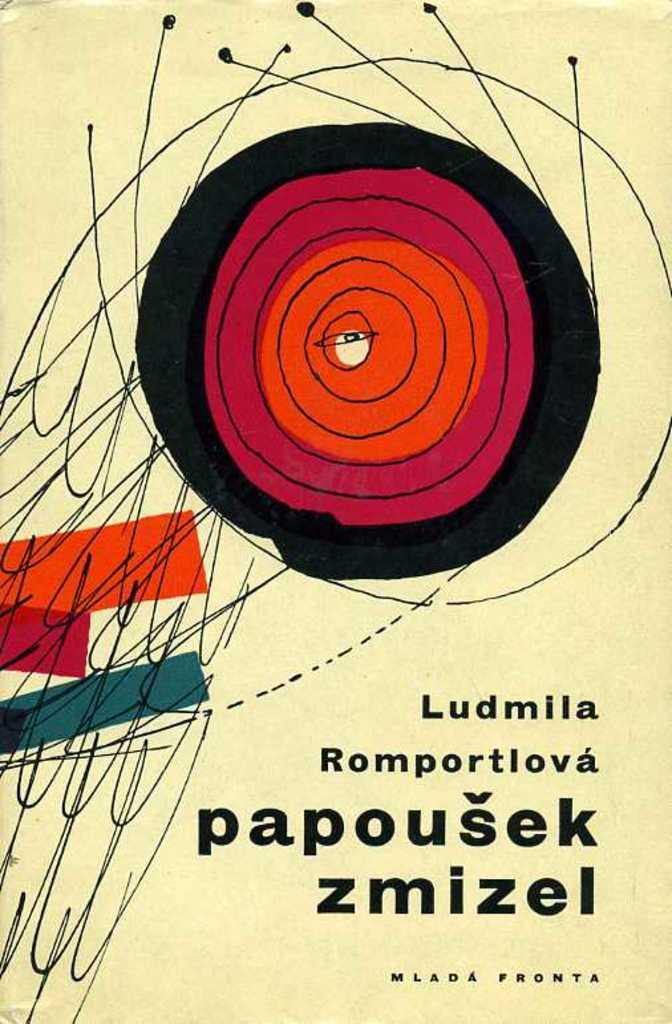<image>
Create a compact narrative representing the image presented. The cover of a book which has the name Ludmila on it. 